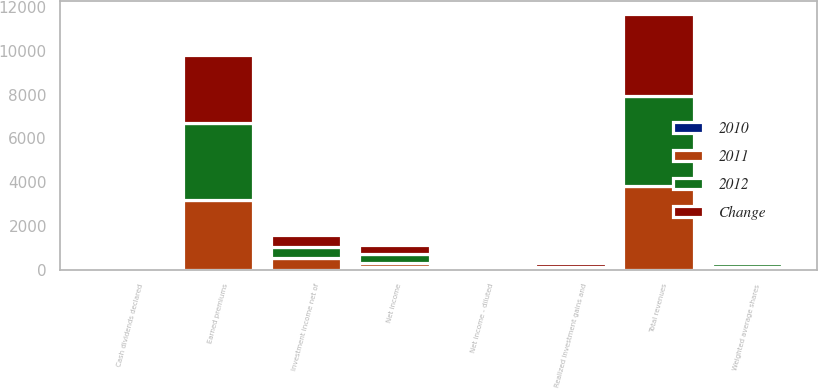Convert chart to OTSL. <chart><loc_0><loc_0><loc_500><loc_500><stacked_bar_chart><ecel><fcel>Earned premiums<fcel>Investment income net of<fcel>Realized investment gains and<fcel>Total revenues<fcel>Net income<fcel>Net income - diluted<fcel>Cash dividends declared<fcel>Weighted average shares<nl><fcel>2012<fcel>3522<fcel>531<fcel>42<fcel>4111<fcel>421<fcel>2.57<fcel>1.62<fcel>154<nl><fcel>2011<fcel>3194<fcel>525<fcel>70<fcel>3803<fcel>164<fcel>1.01<fcel>1.6<fcel>154<nl><fcel>Change<fcel>3082<fcel>518<fcel>159<fcel>3772<fcel>375<fcel>2.3<fcel>1.59<fcel>154<nl><fcel>2010<fcel>10<fcel>1<fcel>40<fcel>8<fcel>157<fcel>154<fcel>1<fcel>0<nl></chart> 